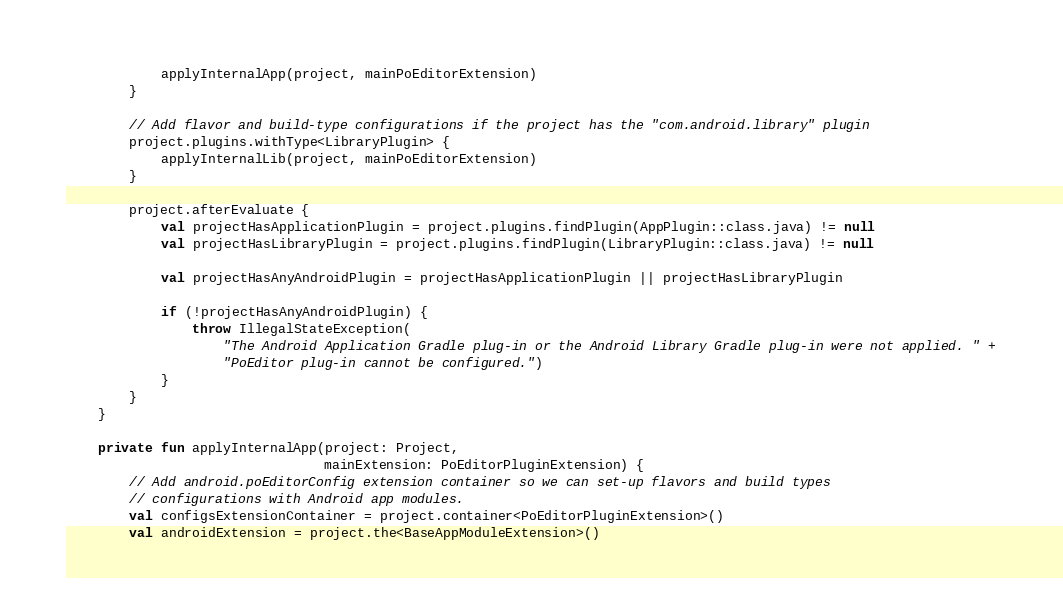Convert code to text. <code><loc_0><loc_0><loc_500><loc_500><_Kotlin_>            applyInternalApp(project, mainPoEditorExtension)
        }

        // Add flavor and build-type configurations if the project has the "com.android.library" plugin
        project.plugins.withType<LibraryPlugin> {
            applyInternalLib(project, mainPoEditorExtension)
        }

        project.afterEvaluate {
            val projectHasApplicationPlugin = project.plugins.findPlugin(AppPlugin::class.java) != null
            val projectHasLibraryPlugin = project.plugins.findPlugin(LibraryPlugin::class.java) != null

            val projectHasAnyAndroidPlugin = projectHasApplicationPlugin || projectHasLibraryPlugin

            if (!projectHasAnyAndroidPlugin) {
                throw IllegalStateException(
                    "The Android Application Gradle plug-in or the Android Library Gradle plug-in were not applied. " +
                    "PoEditor plug-in cannot be configured.")
            }
        }
    }

    private fun applyInternalApp(project: Project,
                                 mainExtension: PoEditorPluginExtension) {
        // Add android.poEditorConfig extension container so we can set-up flavors and build types
        // configurations with Android app modules.
        val configsExtensionContainer = project.container<PoEditorPluginExtension>()
        val androidExtension = project.the<BaseAppModuleExtension>()</code> 